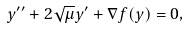Convert formula to latex. <formula><loc_0><loc_0><loc_500><loc_500>y ^ { \prime \prime } + 2 \sqrt { \mu } y ^ { \prime } + \nabla f ( y ) = 0 ,</formula> 